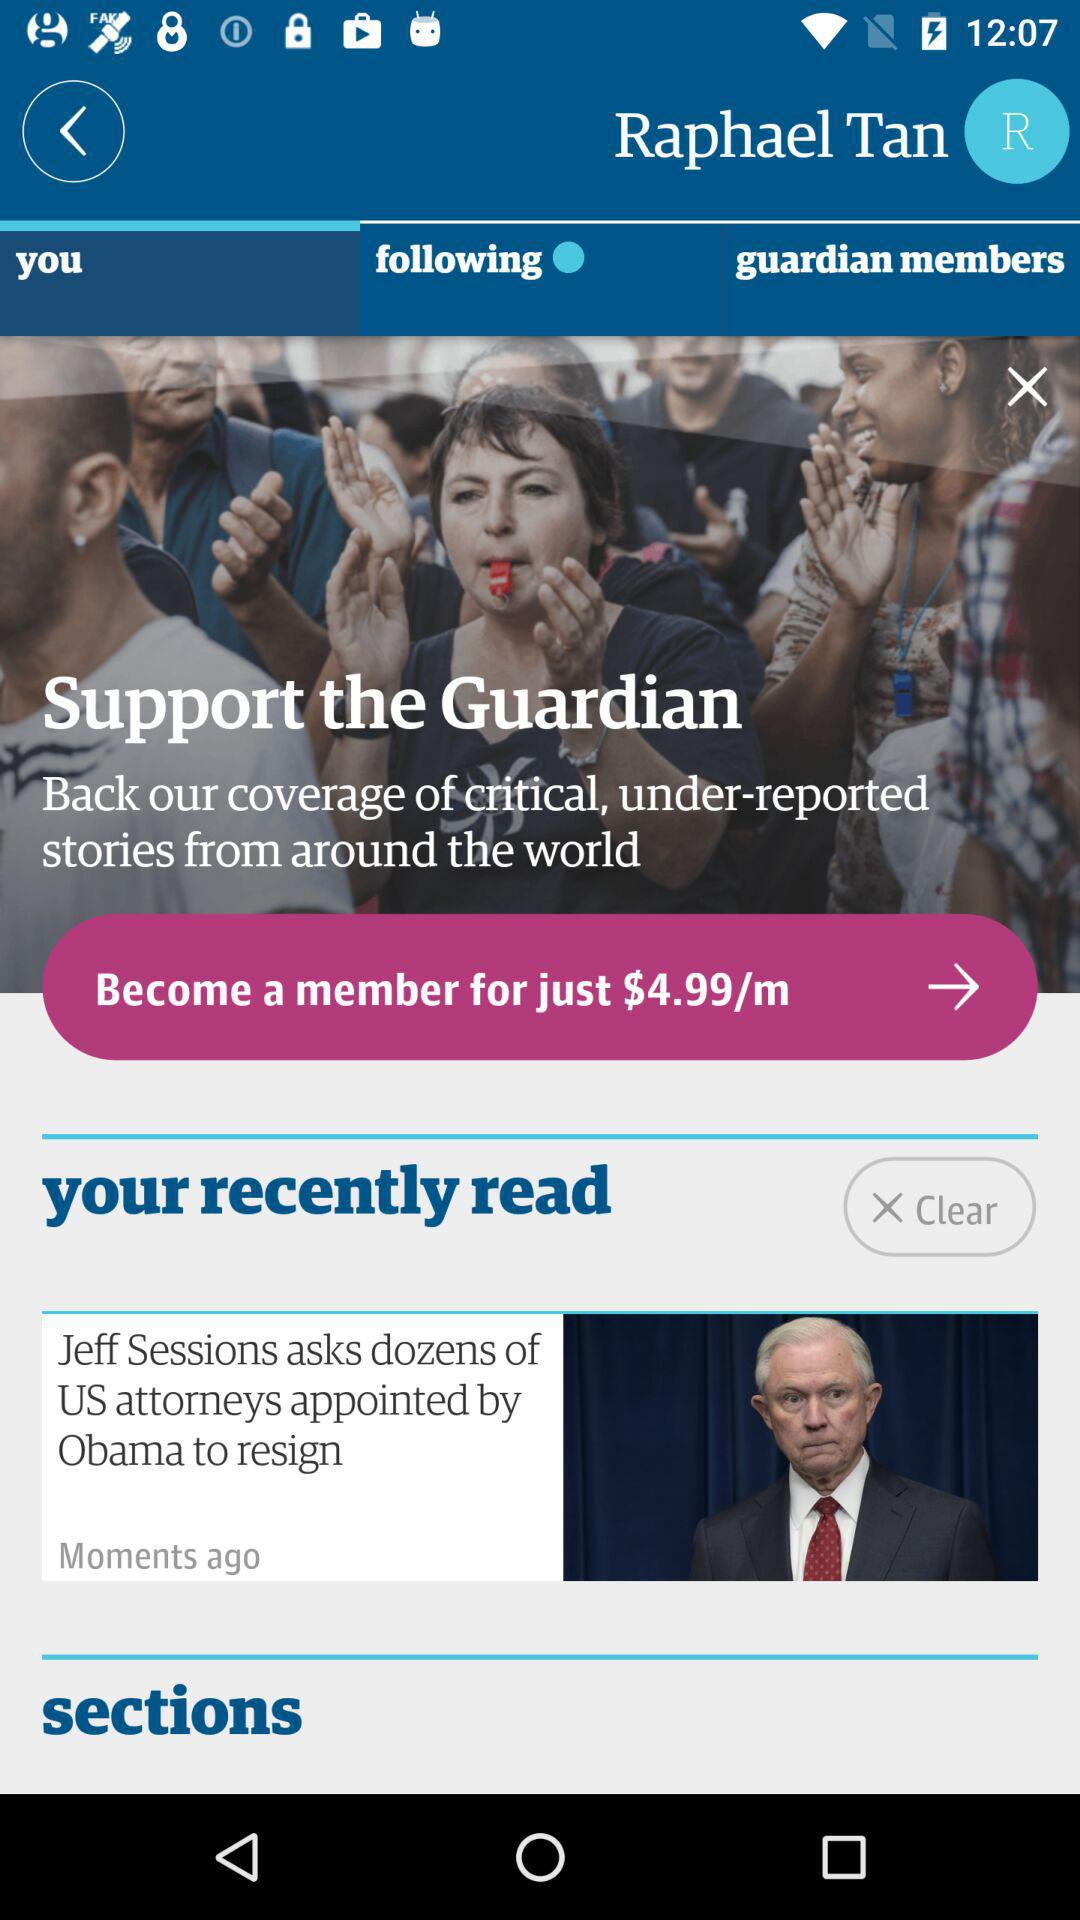What is the headline of the article? What is the headline of the article that you recently read? The headline of the article is "Jeff Sessions asks dozens of US attorneys appointed by Obama to resign". 